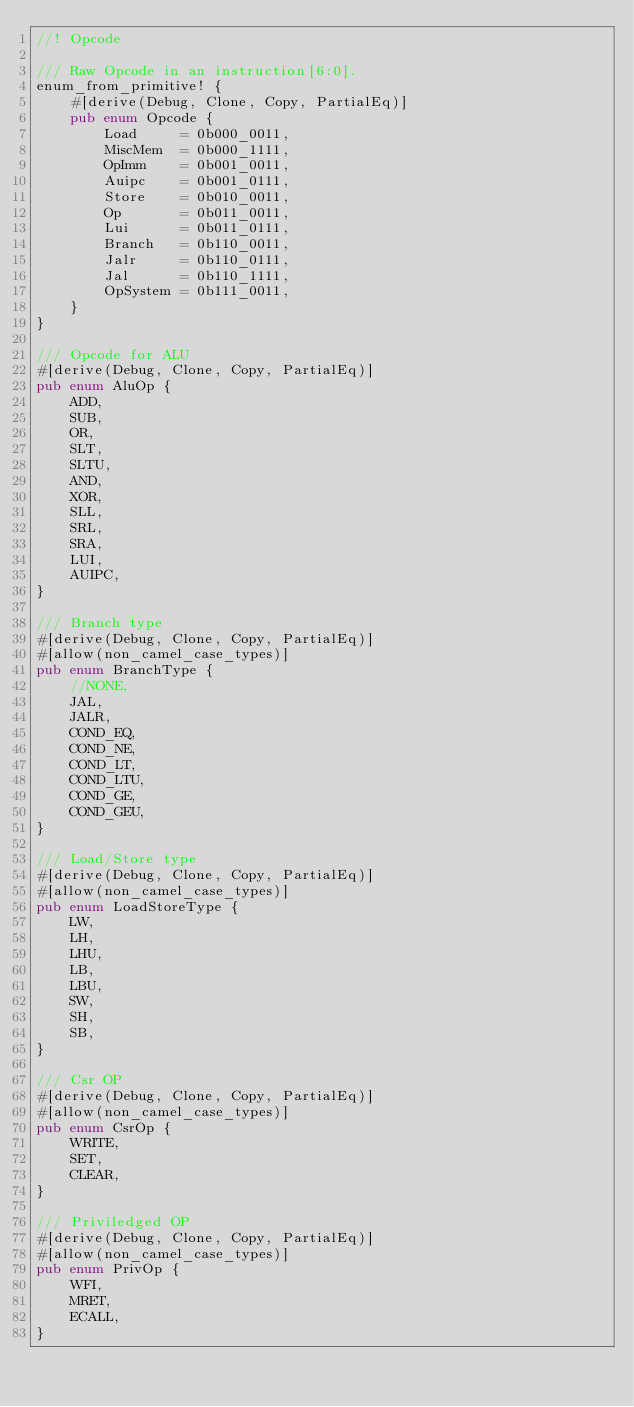<code> <loc_0><loc_0><loc_500><loc_500><_Rust_>//! Opcode

/// Raw Opcode in an instruction[6:0].
enum_from_primitive! {
    #[derive(Debug, Clone, Copy, PartialEq)]
    pub enum Opcode {
        Load     = 0b000_0011,
        MiscMem  = 0b000_1111,
        OpImm    = 0b001_0011,
        Auipc    = 0b001_0111,
        Store    = 0b010_0011,
        Op       = 0b011_0011,
        Lui      = 0b011_0111,
        Branch   = 0b110_0011,
        Jalr     = 0b110_0111,
        Jal      = 0b110_1111,
        OpSystem = 0b111_0011,
    }
}

/// Opcode for ALU
#[derive(Debug, Clone, Copy, PartialEq)]
pub enum AluOp {
    ADD,
    SUB,
    OR,
    SLT,
    SLTU,
    AND,
    XOR,
    SLL,
    SRL,
    SRA,
    LUI,
    AUIPC,
}

/// Branch type
#[derive(Debug, Clone, Copy, PartialEq)]
#[allow(non_camel_case_types)]
pub enum BranchType {
    //NONE,
    JAL,
    JALR,
    COND_EQ,
    COND_NE,
    COND_LT,
    COND_LTU,
    COND_GE,
    COND_GEU,
}

/// Load/Store type
#[derive(Debug, Clone, Copy, PartialEq)]
#[allow(non_camel_case_types)]
pub enum LoadStoreType {
    LW,
    LH,
    LHU,
    LB,
    LBU,
    SW,
    SH,
    SB,
}

/// Csr OP
#[derive(Debug, Clone, Copy, PartialEq)]
#[allow(non_camel_case_types)]
pub enum CsrOp {
    WRITE,
    SET,
    CLEAR,
}

/// Priviledged OP
#[derive(Debug, Clone, Copy, PartialEq)]
#[allow(non_camel_case_types)]
pub enum PrivOp {
    WFI,
    MRET,
    ECALL,
}
</code> 